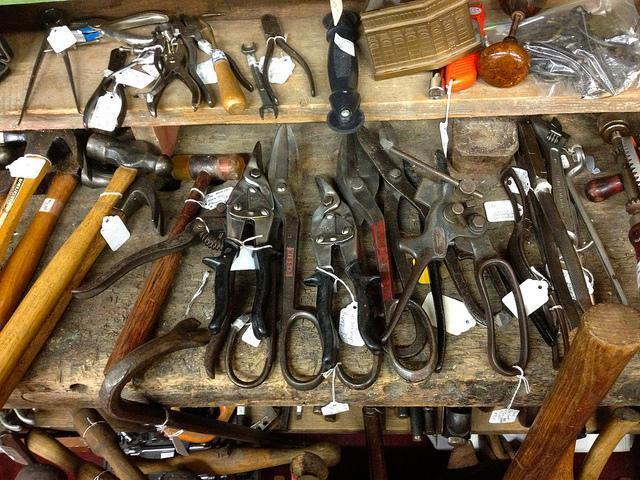How many scissors are there?
Give a very brief answer. 3. 